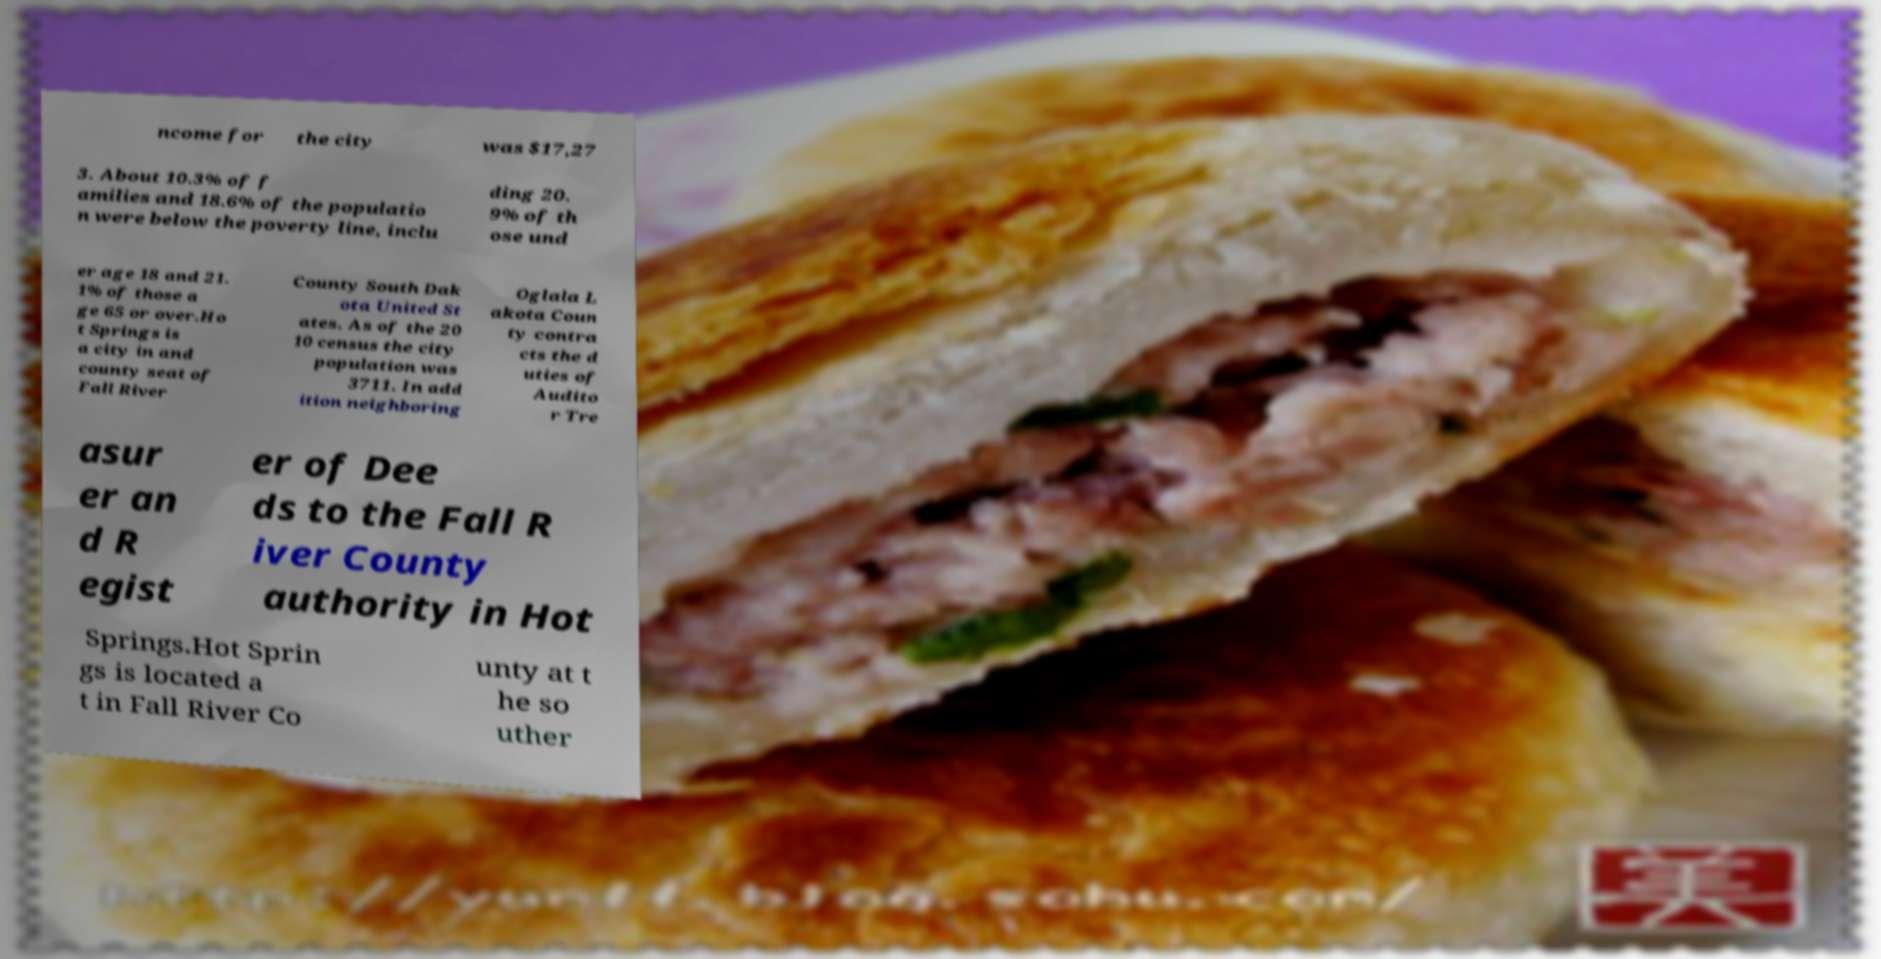Please read and relay the text visible in this image. What does it say? ncome for the city was $17,27 3. About 10.3% of f amilies and 18.6% of the populatio n were below the poverty line, inclu ding 20. 9% of th ose und er age 18 and 21. 1% of those a ge 65 or over.Ho t Springs is a city in and county seat of Fall River County South Dak ota United St ates. As of the 20 10 census the city population was 3711. In add ition neighboring Oglala L akota Coun ty contra cts the d uties of Audito r Tre asur er an d R egist er of Dee ds to the Fall R iver County authority in Hot Springs.Hot Sprin gs is located a t in Fall River Co unty at t he so uther 